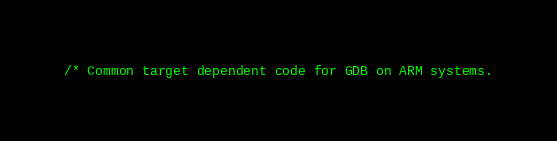Convert code to text. <code><loc_0><loc_0><loc_500><loc_500><_C_>/* Common target dependent code for GDB on ARM systems.
</code> 